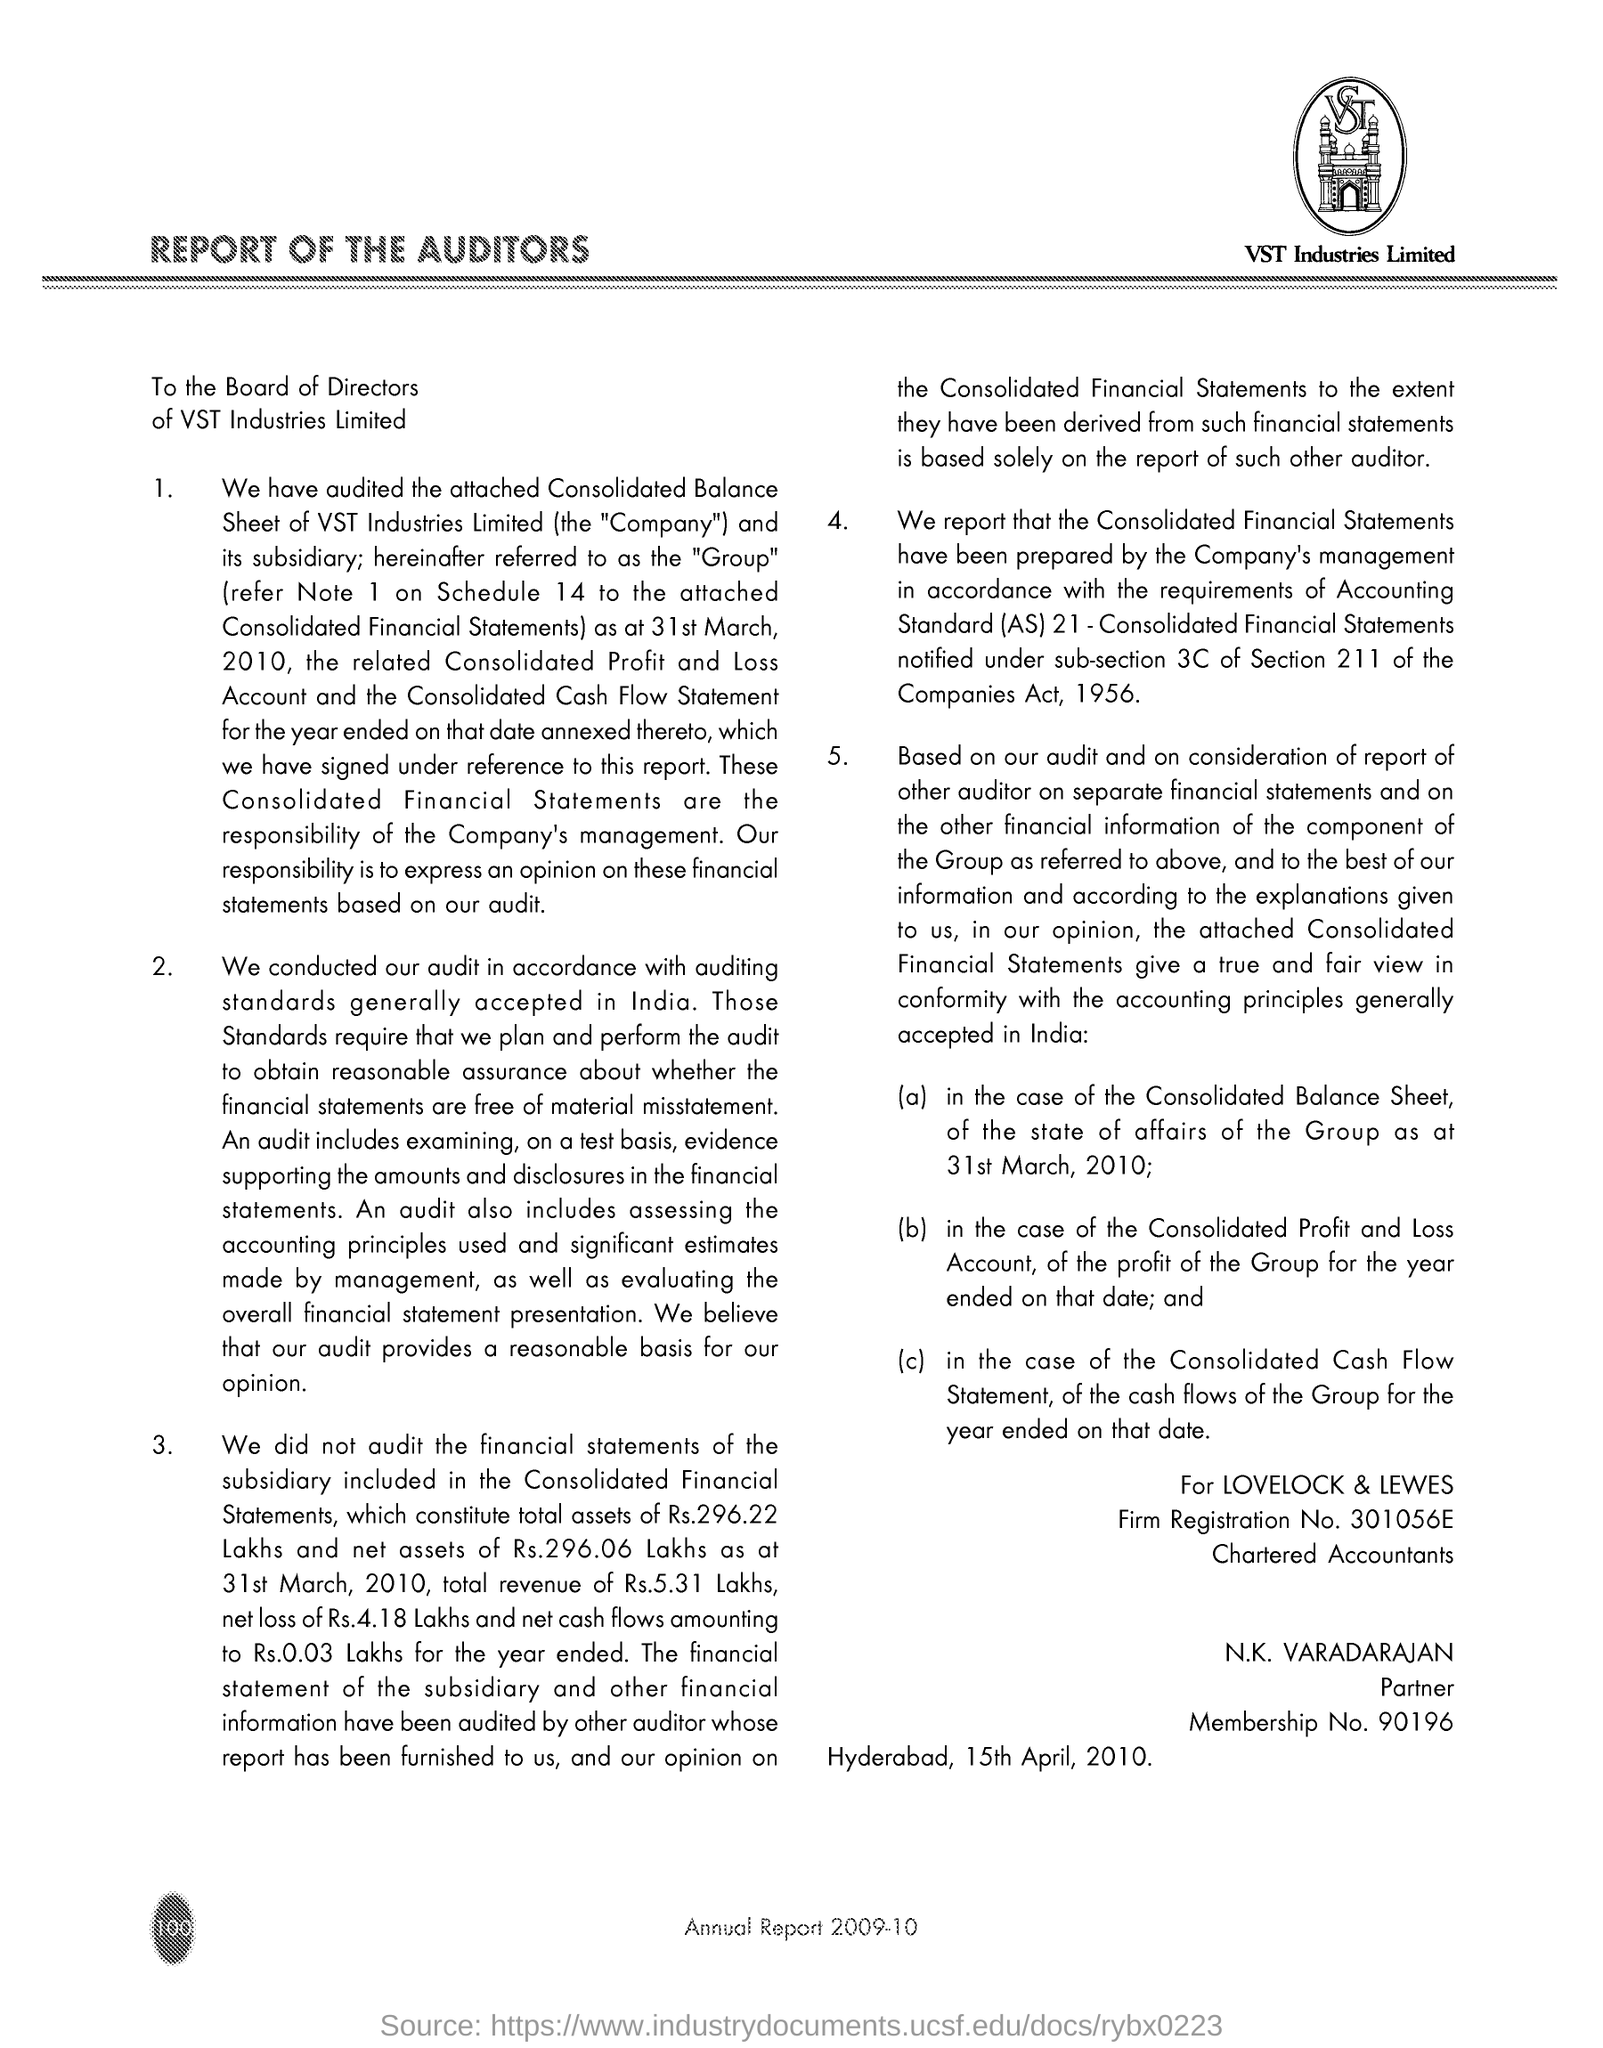Specify some key components in this picture. What is the firm registration number for LOVELOCK & LEWES, as stated in the document? 301056E... N.K. Varadarajan's membership number is 90196... The document indicates that the place of occurrence is Hyderabad and the date is April 15, 2010. 